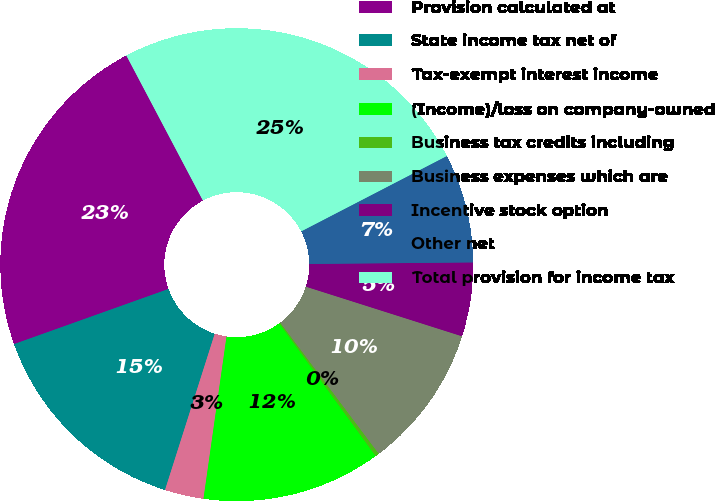Convert chart to OTSL. <chart><loc_0><loc_0><loc_500><loc_500><pie_chart><fcel>Provision calculated at<fcel>State income tax net of<fcel>Tax-exempt interest income<fcel>(Income)/loss on company-owned<fcel>Business tax credits including<fcel>Business expenses which are<fcel>Incentive stock option<fcel>Other net<fcel>Total provision for income tax<nl><fcel>22.73%<fcel>14.64%<fcel>2.66%<fcel>12.24%<fcel>0.26%<fcel>9.85%<fcel>5.05%<fcel>7.45%<fcel>25.13%<nl></chart> 